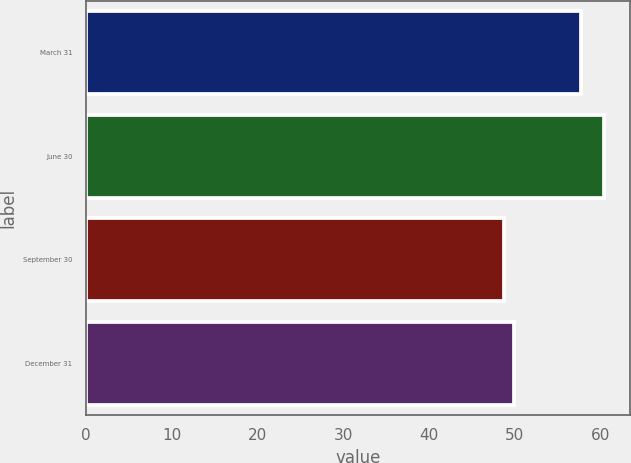Convert chart to OTSL. <chart><loc_0><loc_0><loc_500><loc_500><bar_chart><fcel>March 31<fcel>June 30<fcel>September 30<fcel>December 31<nl><fcel>57.75<fcel>60.46<fcel>48.75<fcel>49.92<nl></chart> 